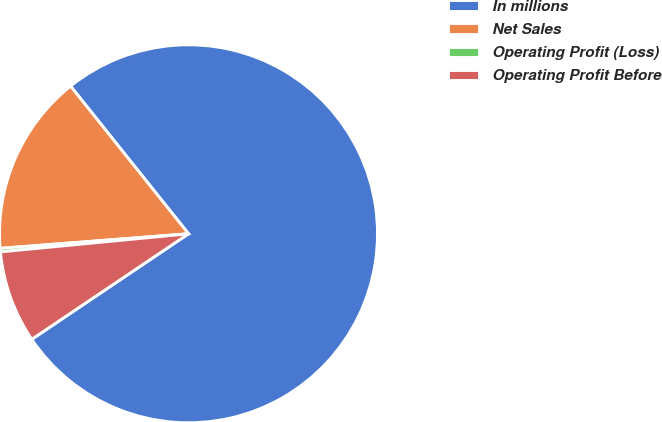Convert chart. <chart><loc_0><loc_0><loc_500><loc_500><pie_chart><fcel>In millions<fcel>Net Sales<fcel>Operating Profit (Loss)<fcel>Operating Profit Before<nl><fcel>76.29%<fcel>15.5%<fcel>0.3%<fcel>7.9%<nl></chart> 